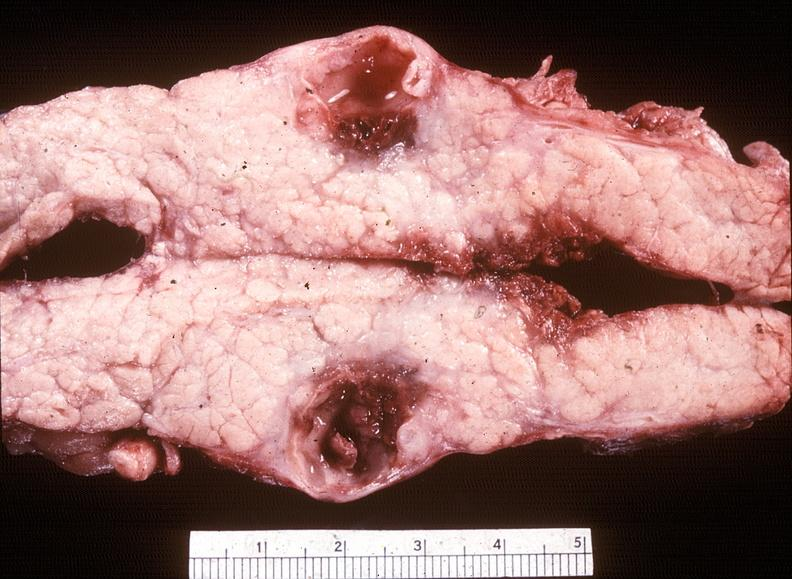does this image show chronic pancreatitis with cyst formation?
Answer the question using a single word or phrase. Yes 